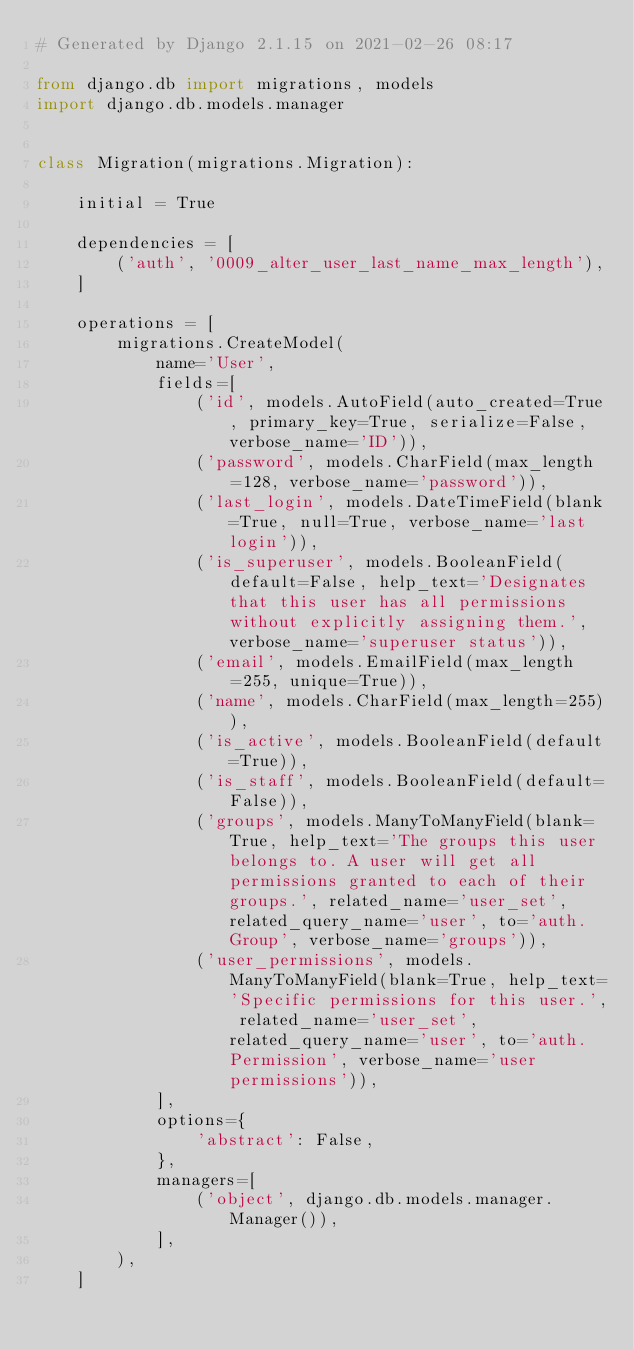Convert code to text. <code><loc_0><loc_0><loc_500><loc_500><_Python_># Generated by Django 2.1.15 on 2021-02-26 08:17

from django.db import migrations, models
import django.db.models.manager


class Migration(migrations.Migration):

    initial = True

    dependencies = [
        ('auth', '0009_alter_user_last_name_max_length'),
    ]

    operations = [
        migrations.CreateModel(
            name='User',
            fields=[
                ('id', models.AutoField(auto_created=True, primary_key=True, serialize=False, verbose_name='ID')),
                ('password', models.CharField(max_length=128, verbose_name='password')),
                ('last_login', models.DateTimeField(blank=True, null=True, verbose_name='last login')),
                ('is_superuser', models.BooleanField(default=False, help_text='Designates that this user has all permissions without explicitly assigning them.', verbose_name='superuser status')),
                ('email', models.EmailField(max_length=255, unique=True)),
                ('name', models.CharField(max_length=255)),
                ('is_active', models.BooleanField(default=True)),
                ('is_staff', models.BooleanField(default=False)),
                ('groups', models.ManyToManyField(blank=True, help_text='The groups this user belongs to. A user will get all permissions granted to each of their groups.', related_name='user_set', related_query_name='user', to='auth.Group', verbose_name='groups')),
                ('user_permissions', models.ManyToManyField(blank=True, help_text='Specific permissions for this user.', related_name='user_set', related_query_name='user', to='auth.Permission', verbose_name='user permissions')),
            ],
            options={
                'abstract': False,
            },
            managers=[
                ('object', django.db.models.manager.Manager()),
            ],
        ),
    ]
</code> 